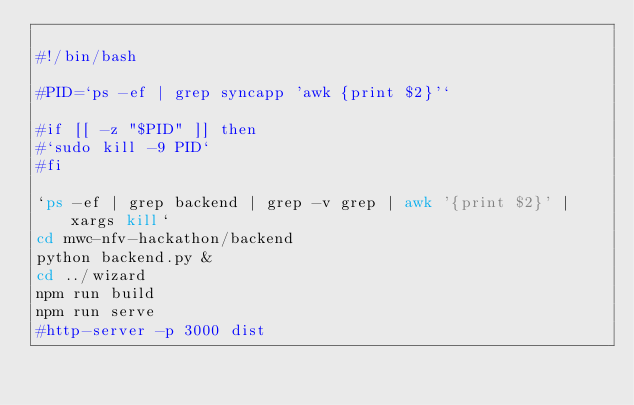<code> <loc_0><loc_0><loc_500><loc_500><_Bash_>
#!/bin/bash

#PID=`ps -ef | grep syncapp 'awk {print $2}'`

#if [[ -z "$PID" ]] then
#`sudo kill -9 PID`
#fi

`ps -ef | grep backend | grep -v grep | awk '{print $2}' | xargs kill`
cd mwc-nfv-hackathon/backend
python backend.py &
cd ../wizard
npm run build
npm run serve
#http-server -p 3000 dist
</code> 